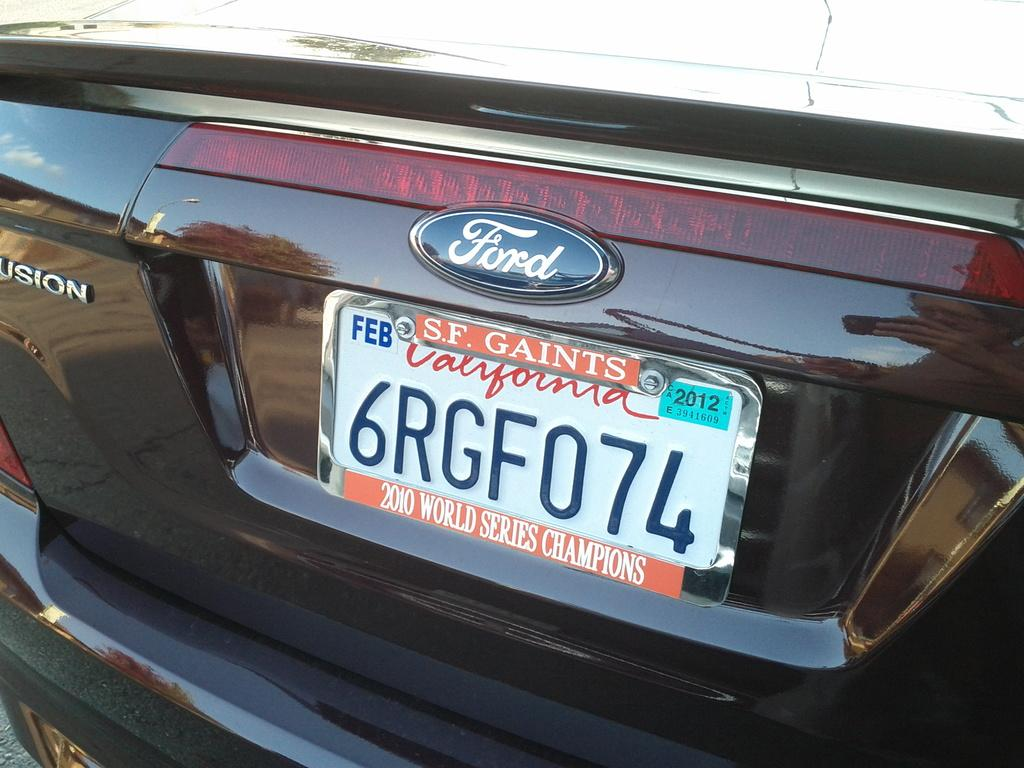Provide a one-sentence caption for the provided image. A dark red ford vehicle with tag number 6RGF074. 